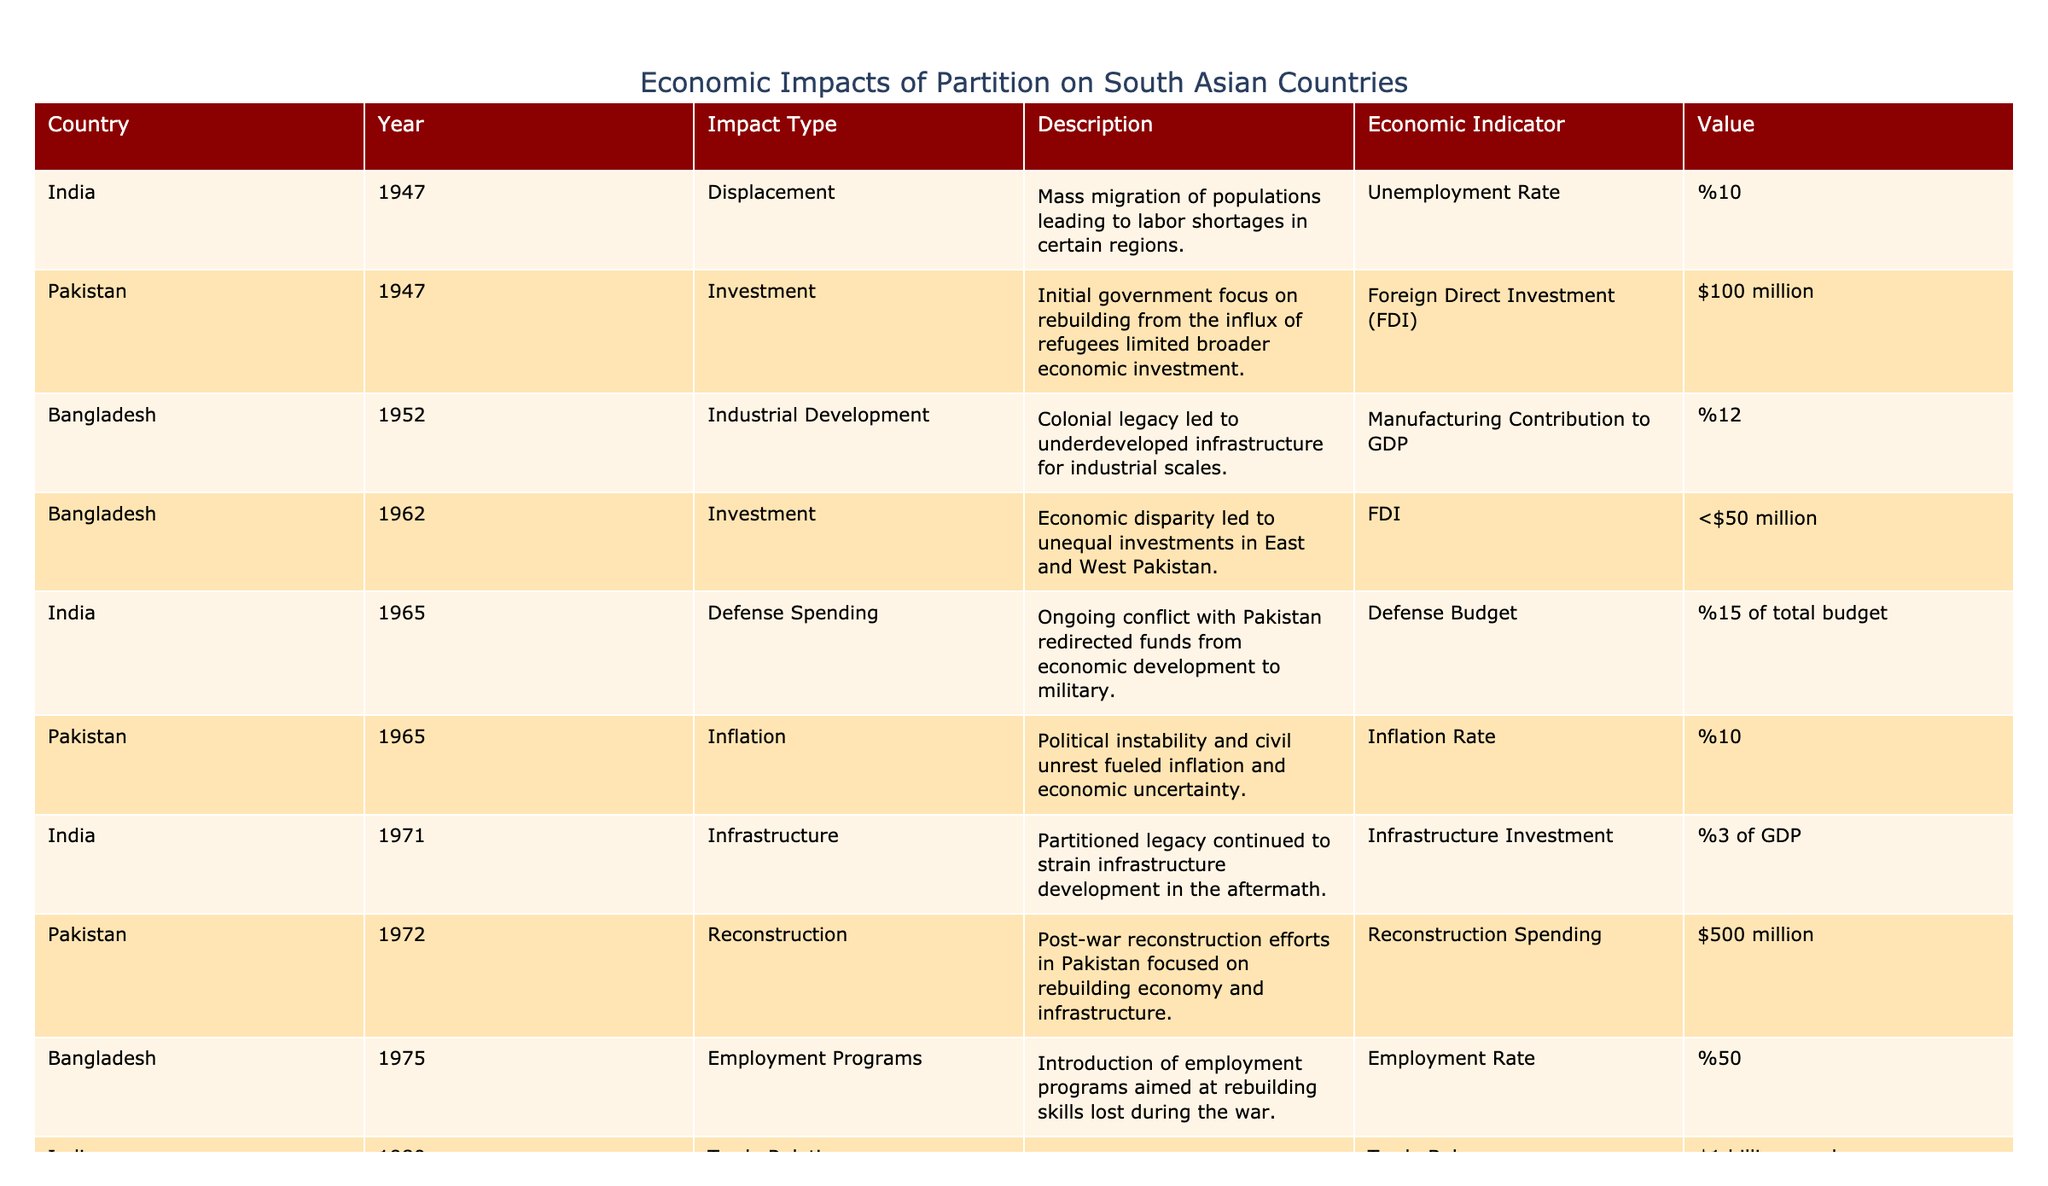What was the unemployment rate in India in 1947? The table directly indicates that the unemployment rate in India in 1947 was 10%.
Answer: 10% What was the foreign direct investment in Pakistan in 1947? According to the table, the foreign direct investment in Pakistan for that year was $100 million.
Answer: $100 million What was the contribution of the manufacturing sector to Bangladesh's GDP in 1952? The table lists the manufacturing contribution to GDP as 12% for Bangladesh in 1952.
Answer: 12% Which year saw the highest infrastructure investment as a percentage of GDP in India? In the table, India shows a 3% investment in infrastructure in 1971 which is the only investment listed, so it's the highest.
Answer: 3% Did Bangladesh see an increase or decrease in foreign direct investment from 1962 to 1972? The table states the FDI was less than $50 million in 1962 and does not provide a value for 1972, suggesting a decrease.
Answer: Decrease What is the total value of reconstruction spending in Pakistan recorded in 1972? The reconstruction spending listed in the table for Pakistan in 1972 is $500 million.
Answer: $500 million What percentage of GDP did remittances account for in Bangladesh in 2015? The table indicates that remittances in Bangladesh were 7% of GDP in 2015.
Answer: 7% What was the average debt to GDP ratio for Pakistan in the years listed? The only data point related to debt to GDP for Pakistan in the table is 70% in 1998, as there are no other values to average with.
Answer: 70% What can be inferred about the investment trends in East and West Pakistan over time? The table shows unequal investments in East and West Pakistan indicated by "less than $50 million" in East Pakistan in 1962, which implies a trend of underinvestment in the East compared to the West.
Answer: Underinvestment in East Pakistan Which country had a higher unemployment rate in the years shown, India in 1947 or Bangladesh in 1952? India had an unemployment rate of 10% in 1947 and the table does not list an unemployment rate for Bangladesh, making it impossible to compare directly. However, given the absence of specific data for Bangladesh, it's reasonable to consider India had the higher reported figure.
Answer: India had a higher reported figure 